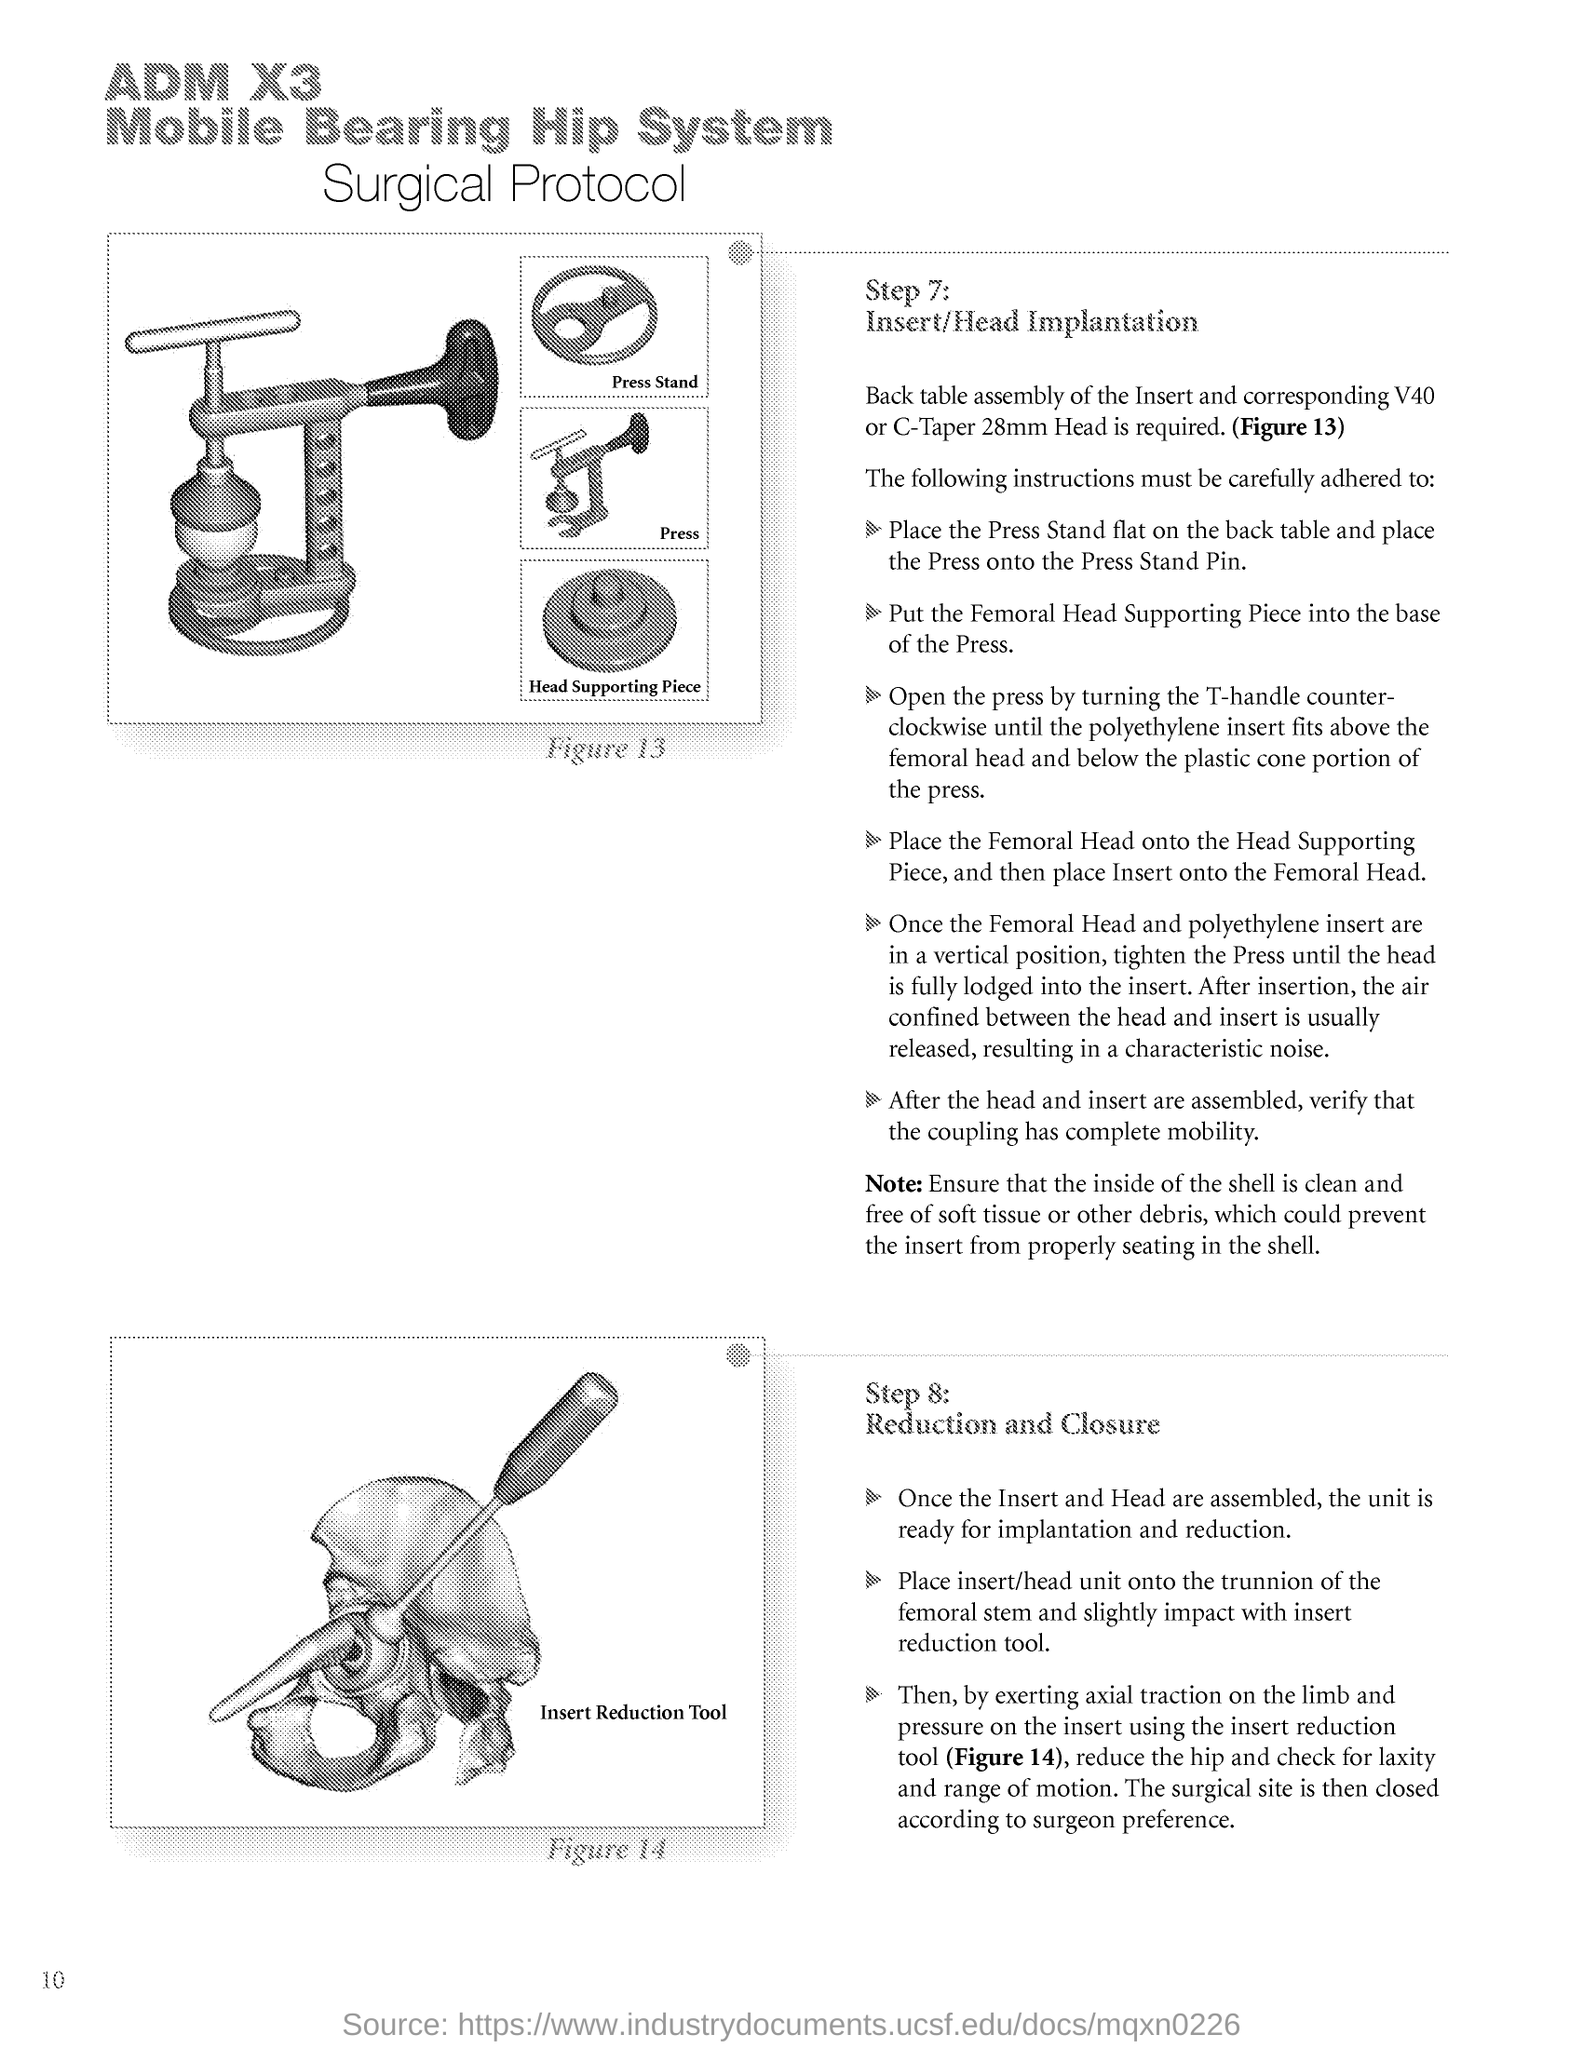Mention a couple of crucial points in this snapshot. Step number 8 in the proof of the Incompleteness Theorem is reduction and closure, which involves showing that a set of sentences with a certain property has a model, and using this to derive a contradiction. The page number is 10. What is Step Number 7? The insertion/head implantation process. 